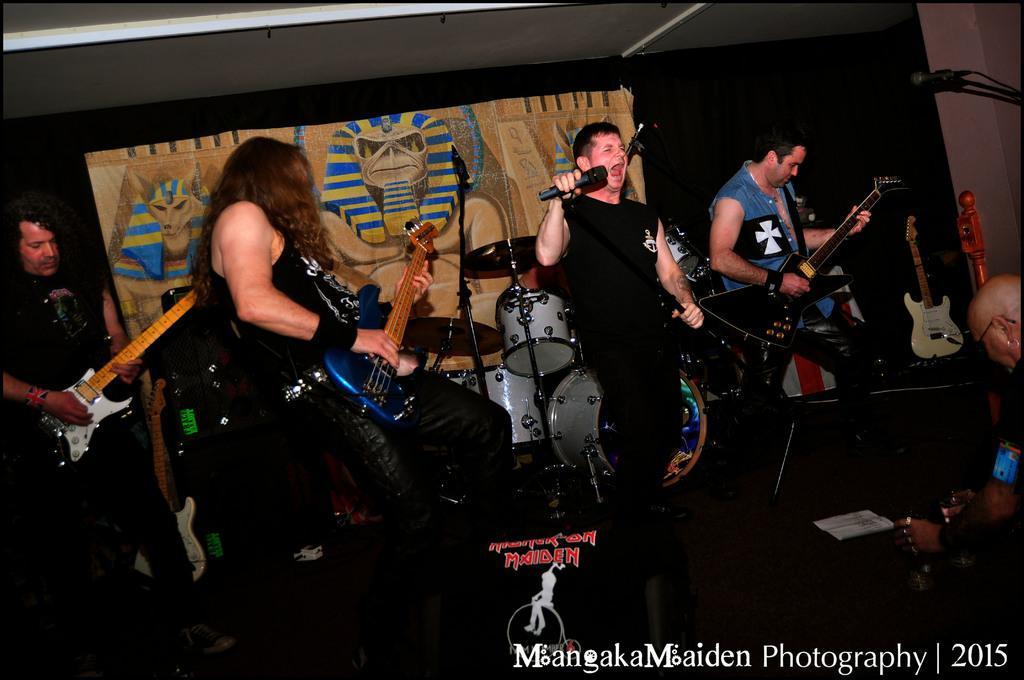Could you give a brief overview of what you see in this image? In the image we can see four persons were standing and holding guitar. The center person holding microphone. In the background we can see banner,wall and guitars. 